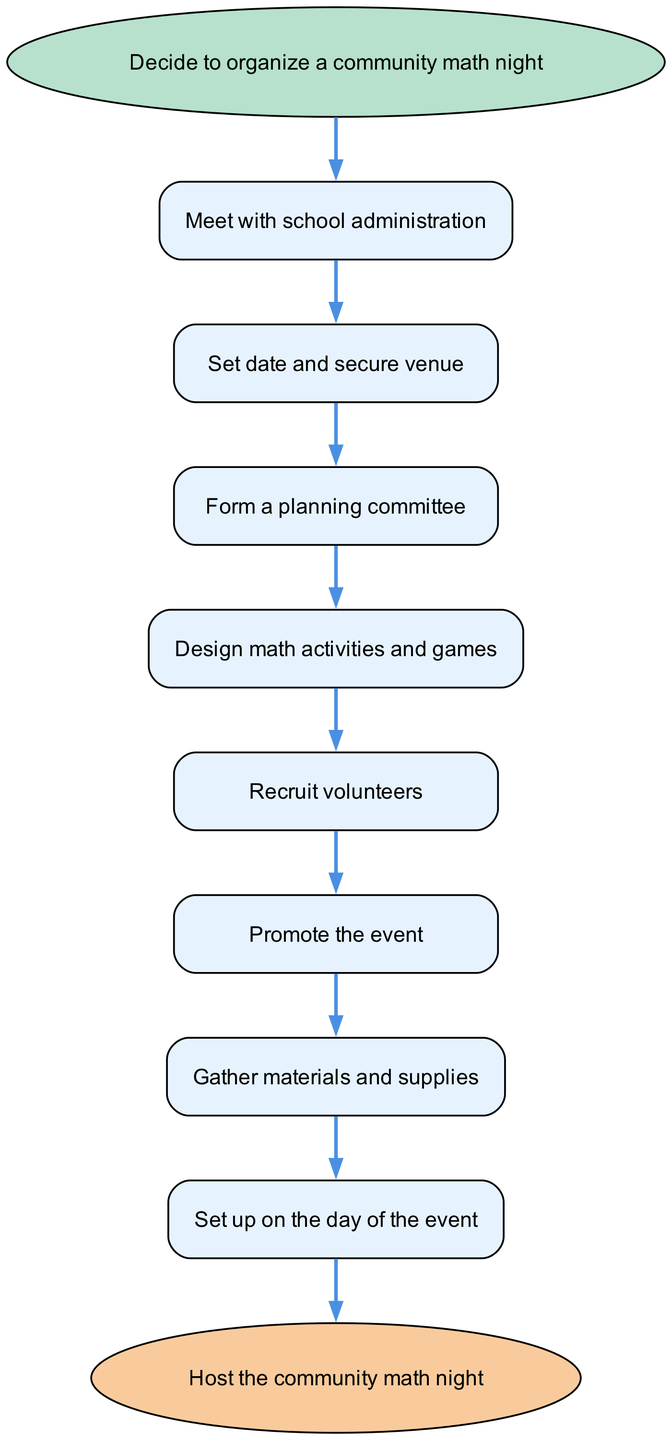What is the first step to organize a community math night? The first step to organize a community math night is "Decide to organize a community math night," as indicated by the starting node in the flowchart.
Answer: Decide to organize a community math night How many total steps are shown in the diagram? To find the total steps, count each node between the starting node and the ending node. There are 8 steps including the starting and ending nodes.
Answer: 8 What is the last action before hosting the event? The last action before hosting the event is "Set up on the day of the event," which is the penultimate step in the flowchart before reaching the end node.
Answer: Set up on the day of the event What follows after meeting with school administration? After "Meet with school administration," the next step is "Set date and secure venue," as shown in the direct connection from the first step to the second.
Answer: Set date and secure venue How many volunteer recruitment steps are there? The only specific mention of a recruitment action is "Recruit volunteers," and it appears as a single step between "Design math activities and games" and "Promote the event." Thus, there is one recruitment step.
Answer: 1 Which step involves preparing materials? The step that involves preparing materials is "Gather materials and supplies," and it is placed just before the event setup step in the flowchart.
Answer: Gather materials and supplies What is the connection between promoting the event and gathering materials? The connection is sequential, where "Promote the event" directly leads to "Gather materials and supplies," indicating that these actions are performed one after the other.
Answer: Sequential Is there any step to design activities before forming a committee? Yes, in the flow, "Design math activities and games" occurs after "Form a planning committee," confirming that activities are designed following the committee formation.
Answer: No 